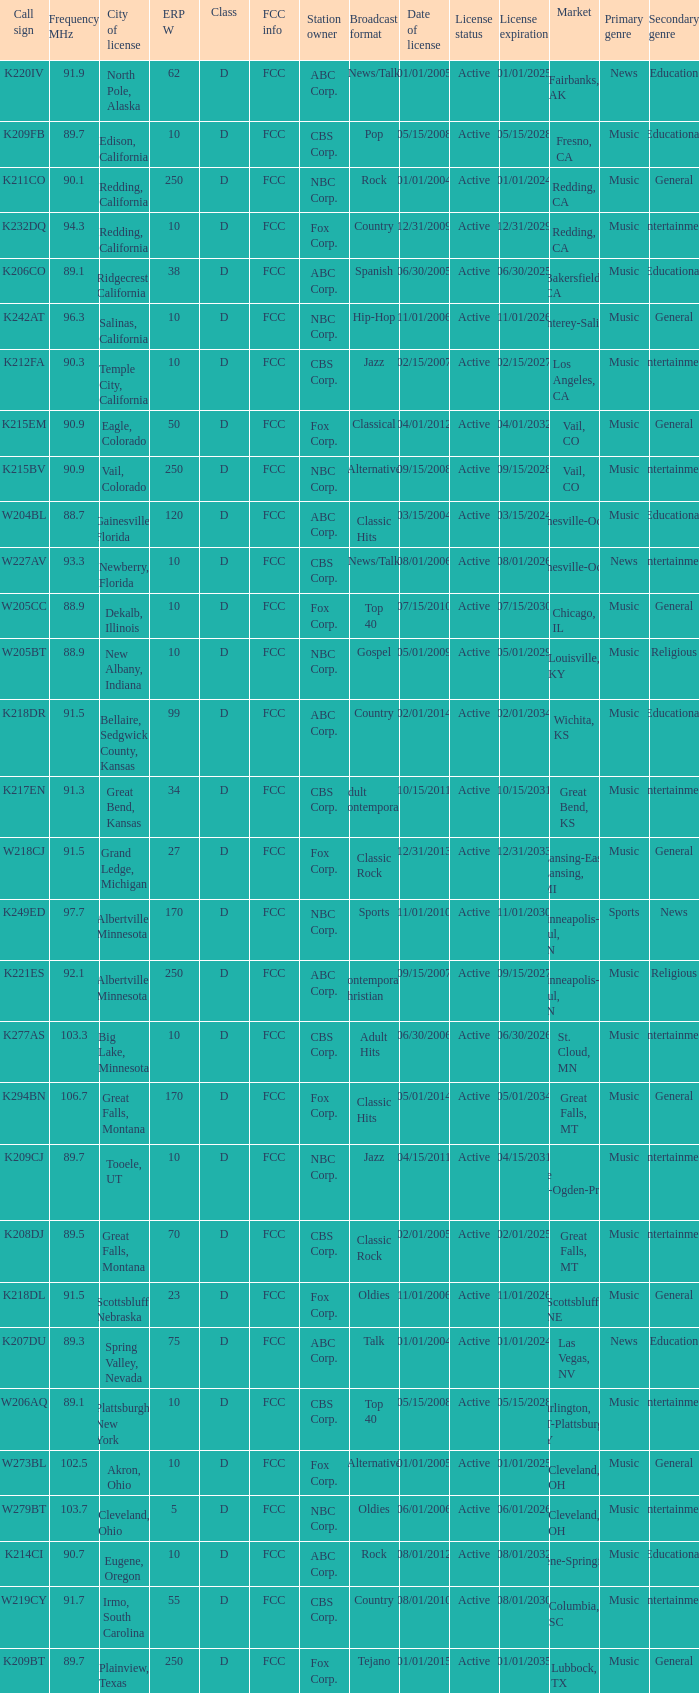What is the highest ERP W of an 89.1 frequency translator? 38.0. 